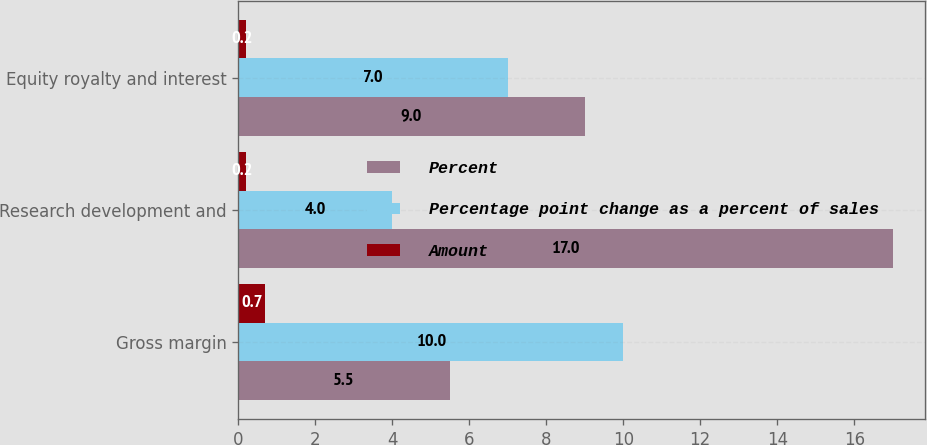Convert chart to OTSL. <chart><loc_0><loc_0><loc_500><loc_500><stacked_bar_chart><ecel><fcel>Gross margin<fcel>Research development and<fcel>Equity royalty and interest<nl><fcel>Percent<fcel>5.5<fcel>17<fcel>9<nl><fcel>Percentage point change as a percent of sales<fcel>10<fcel>4<fcel>7<nl><fcel>Amount<fcel>0.7<fcel>0.2<fcel>0.2<nl></chart> 